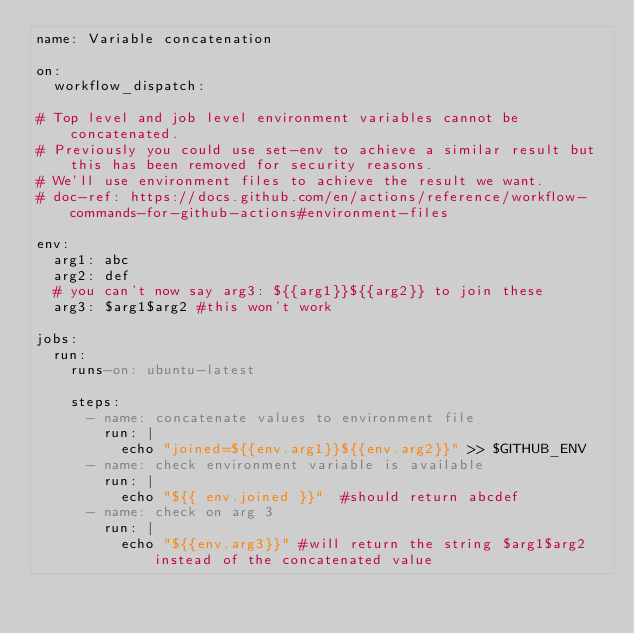Convert code to text. <code><loc_0><loc_0><loc_500><loc_500><_YAML_>name: Variable concatenation

on:
  workflow_dispatch:

# Top level and job level environment variables cannot be concatenated.
# Previously you could use set-env to achieve a similar result but this has been removed for security reasons.
# We'll use environment files to achieve the result we want.
# doc-ref: https://docs.github.com/en/actions/reference/workflow-commands-for-github-actions#environment-files

env:
  arg1: abc
  arg2: def
  # you can't now say arg3: ${{arg1}}${{arg2}} to join these
  arg3: $arg1$arg2 #this won't work
  
jobs:
  run:
    runs-on: ubuntu-latest

    steps:
      - name: concatenate values to environment file
        run: |
          echo "joined=${{env.arg1}}${{env.arg2}}" >> $GITHUB_ENV
      - name: check environment variable is available
        run: |
          echo "${{ env.joined }}"  #should return abcdef
      - name: check on arg 3
        run: |
          echo "${{env.arg3}}" #will return the string $arg1$arg2 instead of the concatenated value
</code> 